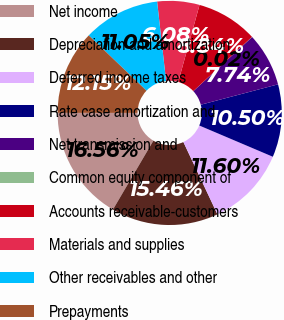Convert chart. <chart><loc_0><loc_0><loc_500><loc_500><pie_chart><fcel>Net income<fcel>Depreciation and amortization<fcel>Deferred income taxes<fcel>Rate case amortization and<fcel>Net transmission and<fcel>Common equity component of<fcel>Accounts receivable-customers<fcel>Materials and supplies<fcel>Other receivables and other<fcel>Prepayments<nl><fcel>16.56%<fcel>15.46%<fcel>11.6%<fcel>10.5%<fcel>7.74%<fcel>0.02%<fcel>8.84%<fcel>6.08%<fcel>11.05%<fcel>12.15%<nl></chart> 